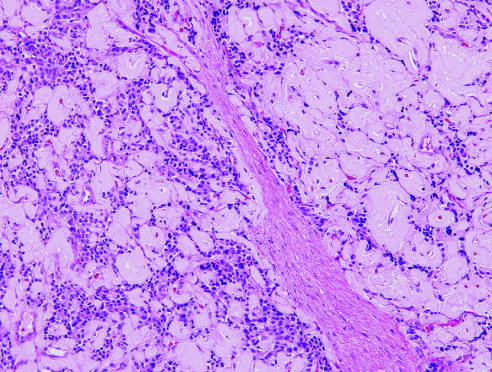what is ancreatic neuroendocrine tumor pannet called?
Answer the question using a single word or phrase. Islet cell tumor 